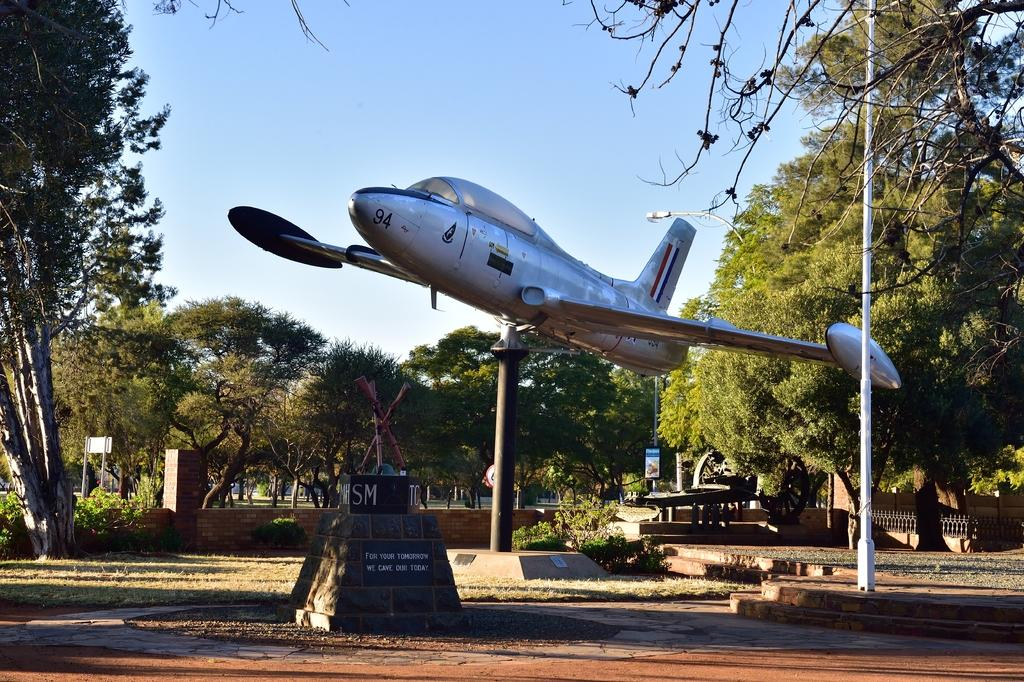What is the main subject of the image? The main subject of the image is an aeroplane. What other objects or structures can be seen in the image? There are poles, plants, boards, a fence, trees, and grass visible in the image. What is visible in the background of the image? The sky is visible in the background of the image. What type of government is depicted in the image? There is no depiction of a government in the image; it primarily features an aeroplane and various objects and structures. How much power is being generated by the plants in the image? The plants in the image are not generating power; they are simply plants. 